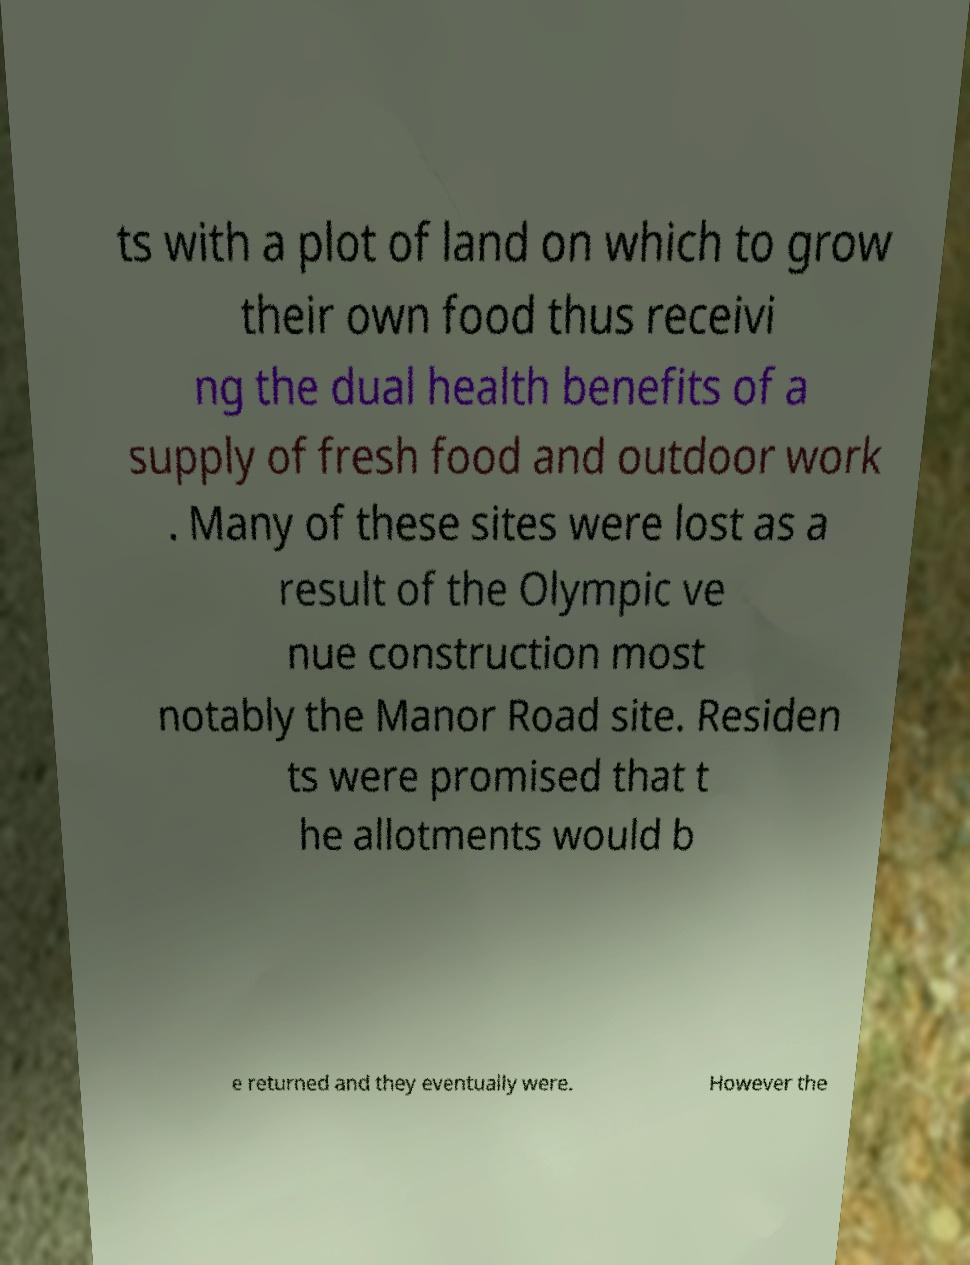What messages or text are displayed in this image? I need them in a readable, typed format. ts with a plot of land on which to grow their own food thus receivi ng the dual health benefits of a supply of fresh food and outdoor work . Many of these sites were lost as a result of the Olympic ve nue construction most notably the Manor Road site. Residen ts were promised that t he allotments would b e returned and they eventually were. However the 